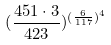<formula> <loc_0><loc_0><loc_500><loc_500>( \frac { 4 5 1 \cdot 3 } { 4 2 3 } ) ^ { ( \frac { 6 } { 1 1 7 } ) ^ { 4 } }</formula> 